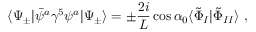<formula> <loc_0><loc_0><loc_500><loc_500>\langle \Psi _ { \pm } | \bar { \psi } ^ { a } \gamma ^ { 5 } \psi ^ { a } | \Psi _ { \pm } \rangle = \pm \frac { 2 i } { L } \cos \alpha _ { 0 } \langle \tilde { \Phi } _ { I } | \tilde { \Phi } _ { I I } \rangle \ ,</formula> 